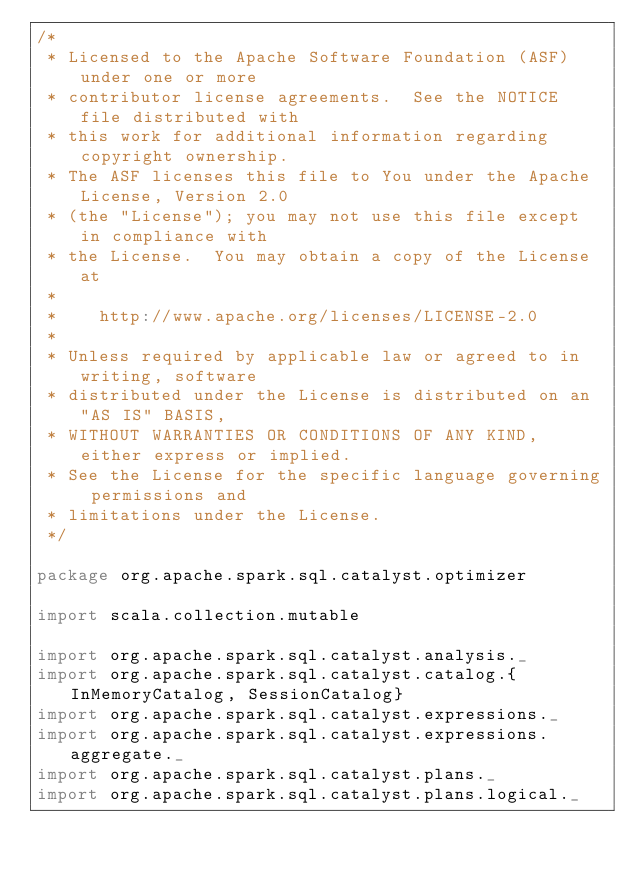<code> <loc_0><loc_0><loc_500><loc_500><_Scala_>/*
 * Licensed to the Apache Software Foundation (ASF) under one or more
 * contributor license agreements.  See the NOTICE file distributed with
 * this work for additional information regarding copyright ownership.
 * The ASF licenses this file to You under the Apache License, Version 2.0
 * (the "License"); you may not use this file except in compliance with
 * the License.  You may obtain a copy of the License at
 *
 *    http://www.apache.org/licenses/LICENSE-2.0
 *
 * Unless required by applicable law or agreed to in writing, software
 * distributed under the License is distributed on an "AS IS" BASIS,
 * WITHOUT WARRANTIES OR CONDITIONS OF ANY KIND, either express or implied.
 * See the License for the specific language governing permissions and
 * limitations under the License.
 */

package org.apache.spark.sql.catalyst.optimizer

import scala.collection.mutable

import org.apache.spark.sql.catalyst.analysis._
import org.apache.spark.sql.catalyst.catalog.{InMemoryCatalog, SessionCatalog}
import org.apache.spark.sql.catalyst.expressions._
import org.apache.spark.sql.catalyst.expressions.aggregate._
import org.apache.spark.sql.catalyst.plans._
import org.apache.spark.sql.catalyst.plans.logical._</code> 